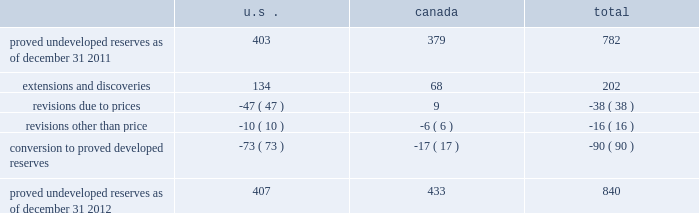Devon energy corporation and subsidiaries notes to consolidated financial statements 2013 ( continued ) proved undeveloped reserves the table presents the changes in devon 2019s total proved undeveloped reserves during 2012 ( in mmboe ) . .
At december 31 , 2012 , devon had 840 mmboe of proved undeveloped reserves .
This represents a 7 percent increase as compared to 2011 and represents 28 percent of its total proved reserves .
Drilling and development activities increased devon 2019s proved undeveloped reserves 203 mmboe and resulted in the conversion of 90 mmboe , or 12 percent , of the 2011 proved undeveloped reserves to proved developed reserves .
Costs incurred related to the development and conversion of devon 2019s proved undeveloped reserves were $ 1.3 billion for 2012 .
Additionally , revisions other than price decreased devon 2019s proved undeveloped reserves 16 mmboe primarily due to its evaluation of certain u.s .
Onshore dry-gas areas , which it does not expect to develop in the next five years .
The largest revisions relate to the dry-gas areas at carthage in east texas and the barnett shale in north texas .
A significant amount of devon 2019s proved undeveloped reserves at the end of 2012 largely related to its jackfish operations .
At december 31 , 2012 and 2011 , devon 2019s jackfish proved undeveloped reserves were 429 mmboe and 367 mmboe , respectively .
Development schedules for the jackfish reserves are primarily controlled by the need to keep the processing plants at their 35000 barrel daily facility capacity .
Processing plant capacity is controlled by factors such as total steam processing capacity , steam-oil ratios and air quality discharge permits .
As a result , these reserves are classified as proved undeveloped for more than five years .
Currently , the development schedule for these reserves extends though the year 2031 .
Price revisions 2012 - reserves decreased 171 mmboe primarily due to lower gas prices .
Of this decrease , 100 mmboe related to the barnett shale and 25 mmboe related to the rocky mountain area .
2011 - reserves decreased 21 mmboe due to lower gas prices and higher oil prices .
The higher oil prices increased devon 2019s canadian royalty burden , which reduced devon 2019s oil reserves .
2010 - reserves increased 72 mmboe due to higher gas prices , partially offset by the effect of higher oil prices .
The higher oil prices increased devon 2019s canadian royalty burden , which reduced devon 2019s oil reserves .
Of the 72 mmboe price revisions , 43 mmboe related to the barnett shale and 22 mmboe related to the rocky mountain area .
Revisions other than price total revisions other than price for 2012 and 2011 primarily related to devon 2019s evaluation of certain dry gas regions noted in the proved undeveloped reserves discussion above .
Total revisions other than price for 2010 primarily related to devon 2019s drilling and development in the barnett shale. .
What percentage of total proved undeveloped reserves from canada from 2011-2012 was its proved undeveloped reserves as of dec 31 , 2011? 
Computations: ((379 / (379 + 433)) * 100)
Answer: 46.67488. 